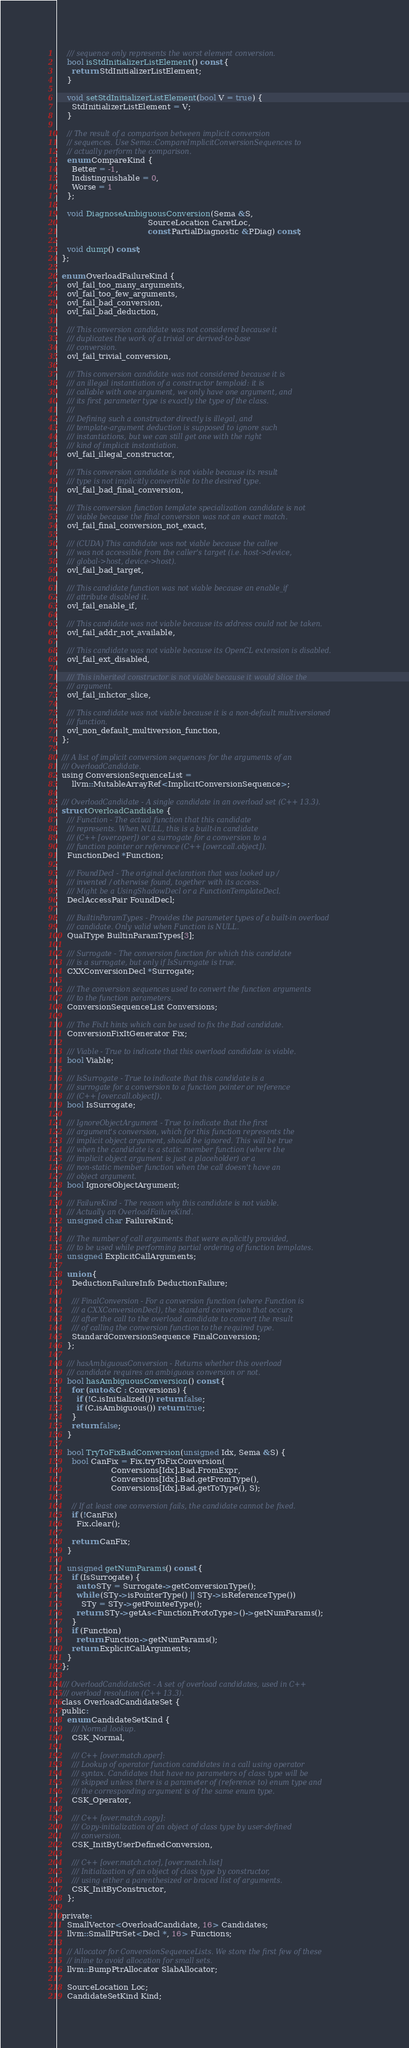<code> <loc_0><loc_0><loc_500><loc_500><_C_>    /// sequence only represents the worst element conversion.
    bool isStdInitializerListElement() const {
      return StdInitializerListElement;
    }

    void setStdInitializerListElement(bool V = true) {
      StdInitializerListElement = V;
    }

    // The result of a comparison between implicit conversion
    // sequences. Use Sema::CompareImplicitConversionSequences to
    // actually perform the comparison.
    enum CompareKind {
      Better = -1,
      Indistinguishable = 0,
      Worse = 1
    };

    void DiagnoseAmbiguousConversion(Sema &S,
                                     SourceLocation CaretLoc,
                                     const PartialDiagnostic &PDiag) const;

    void dump() const;
  };

  enum OverloadFailureKind {
    ovl_fail_too_many_arguments,
    ovl_fail_too_few_arguments,
    ovl_fail_bad_conversion,
    ovl_fail_bad_deduction,

    /// This conversion candidate was not considered because it
    /// duplicates the work of a trivial or derived-to-base
    /// conversion.
    ovl_fail_trivial_conversion,

    /// This conversion candidate was not considered because it is
    /// an illegal instantiation of a constructor temploid: it is
    /// callable with one argument, we only have one argument, and
    /// its first parameter type is exactly the type of the class.
    ///
    /// Defining such a constructor directly is illegal, and
    /// template-argument deduction is supposed to ignore such
    /// instantiations, but we can still get one with the right
    /// kind of implicit instantiation.
    ovl_fail_illegal_constructor,

    /// This conversion candidate is not viable because its result
    /// type is not implicitly convertible to the desired type.
    ovl_fail_bad_final_conversion,

    /// This conversion function template specialization candidate is not
    /// viable because the final conversion was not an exact match.
    ovl_fail_final_conversion_not_exact,

    /// (CUDA) This candidate was not viable because the callee
    /// was not accessible from the caller's target (i.e. host->device,
    /// global->host, device->host).
    ovl_fail_bad_target,

    /// This candidate function was not viable because an enable_if
    /// attribute disabled it.
    ovl_fail_enable_if,

    /// This candidate was not viable because its address could not be taken.
    ovl_fail_addr_not_available,

    /// This candidate was not viable because its OpenCL extension is disabled.
    ovl_fail_ext_disabled,

    /// This inherited constructor is not viable because it would slice the
    /// argument.
    ovl_fail_inhctor_slice,

    /// This candidate was not viable because it is a non-default multiversioned
    /// function.
    ovl_non_default_multiversion_function,
  };

  /// A list of implicit conversion sequences for the arguments of an
  /// OverloadCandidate.
  using ConversionSequenceList =
      llvm::MutableArrayRef<ImplicitConversionSequence>;

  /// OverloadCandidate - A single candidate in an overload set (C++ 13.3).
  struct OverloadCandidate {
    /// Function - The actual function that this candidate
    /// represents. When NULL, this is a built-in candidate
    /// (C++ [over.oper]) or a surrogate for a conversion to a
    /// function pointer or reference (C++ [over.call.object]).
    FunctionDecl *Function;

    /// FoundDecl - The original declaration that was looked up /
    /// invented / otherwise found, together with its access.
    /// Might be a UsingShadowDecl or a FunctionTemplateDecl.
    DeclAccessPair FoundDecl;

    /// BuiltinParamTypes - Provides the parameter types of a built-in overload
    /// candidate. Only valid when Function is NULL.
    QualType BuiltinParamTypes[3];

    /// Surrogate - The conversion function for which this candidate
    /// is a surrogate, but only if IsSurrogate is true.
    CXXConversionDecl *Surrogate;

    /// The conversion sequences used to convert the function arguments
    /// to the function parameters.
    ConversionSequenceList Conversions;

    /// The FixIt hints which can be used to fix the Bad candidate.
    ConversionFixItGenerator Fix;

    /// Viable - True to indicate that this overload candidate is viable.
    bool Viable;

    /// IsSurrogate - True to indicate that this candidate is a
    /// surrogate for a conversion to a function pointer or reference
    /// (C++ [over.call.object]).
    bool IsSurrogate;

    /// IgnoreObjectArgument - True to indicate that the first
    /// argument's conversion, which for this function represents the
    /// implicit object argument, should be ignored. This will be true
    /// when the candidate is a static member function (where the
    /// implicit object argument is just a placeholder) or a
    /// non-static member function when the call doesn't have an
    /// object argument.
    bool IgnoreObjectArgument;

    /// FailureKind - The reason why this candidate is not viable.
    /// Actually an OverloadFailureKind.
    unsigned char FailureKind;

    /// The number of call arguments that were explicitly provided,
    /// to be used while performing partial ordering of function templates.
    unsigned ExplicitCallArguments;

    union {
      DeductionFailureInfo DeductionFailure;
      
      /// FinalConversion - For a conversion function (where Function is
      /// a CXXConversionDecl), the standard conversion that occurs
      /// after the call to the overload candidate to convert the result
      /// of calling the conversion function to the required type.
      StandardConversionSequence FinalConversion;
    };

    /// hasAmbiguousConversion - Returns whether this overload
    /// candidate requires an ambiguous conversion or not.
    bool hasAmbiguousConversion() const {
      for (auto &C : Conversions) {
        if (!C.isInitialized()) return false;
        if (C.isAmbiguous()) return true;
      }
      return false;
    }

    bool TryToFixBadConversion(unsigned Idx, Sema &S) {
      bool CanFix = Fix.tryToFixConversion(
                      Conversions[Idx].Bad.FromExpr,
                      Conversions[Idx].Bad.getFromType(),
                      Conversions[Idx].Bad.getToType(), S);

      // If at least one conversion fails, the candidate cannot be fixed.
      if (!CanFix)
        Fix.clear();

      return CanFix;
    }

    unsigned getNumParams() const {
      if (IsSurrogate) {
        auto STy = Surrogate->getConversionType();
        while (STy->isPointerType() || STy->isReferenceType())
          STy = STy->getPointeeType();
        return STy->getAs<FunctionProtoType>()->getNumParams();
      }
      if (Function)
        return Function->getNumParams();
      return ExplicitCallArguments;
    }
  };

  /// OverloadCandidateSet - A set of overload candidates, used in C++
  /// overload resolution (C++ 13.3).
  class OverloadCandidateSet {
  public:
    enum CandidateSetKind {
      /// Normal lookup.
      CSK_Normal,

      /// C++ [over.match.oper]:
      /// Lookup of operator function candidates in a call using operator
      /// syntax. Candidates that have no parameters of class type will be
      /// skipped unless there is a parameter of (reference to) enum type and
      /// the corresponding argument is of the same enum type.
      CSK_Operator,

      /// C++ [over.match.copy]:
      /// Copy-initialization of an object of class type by user-defined
      /// conversion.
      CSK_InitByUserDefinedConversion,

      /// C++ [over.match.ctor], [over.match.list]
      /// Initialization of an object of class type by constructor,
      /// using either a parenthesized or braced list of arguments.
      CSK_InitByConstructor,
    };

  private:
    SmallVector<OverloadCandidate, 16> Candidates;
    llvm::SmallPtrSet<Decl *, 16> Functions;

    // Allocator for ConversionSequenceLists. We store the first few of these
    // inline to avoid allocation for small sets.
    llvm::BumpPtrAllocator SlabAllocator;

    SourceLocation Loc;
    CandidateSetKind Kind;
</code> 